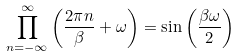Convert formula to latex. <formula><loc_0><loc_0><loc_500><loc_500>\prod _ { n = - \infty } ^ { \infty } \left ( \frac { 2 \pi n } { \beta } + \omega \right ) = \sin \left ( \frac { \beta \omega } { 2 } \right )</formula> 